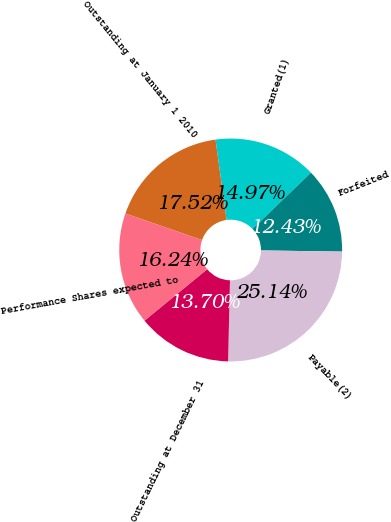Convert chart to OTSL. <chart><loc_0><loc_0><loc_500><loc_500><pie_chart><fcel>Outstanding at January 1 2010<fcel>Granted(1)<fcel>Forfeited<fcel>Payable(2)<fcel>Outstanding at December 31<fcel>Performance Shares expected to<nl><fcel>17.52%<fcel>14.97%<fcel>12.43%<fcel>25.14%<fcel>13.7%<fcel>16.24%<nl></chart> 